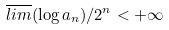<formula> <loc_0><loc_0><loc_500><loc_500>\overline { l i m } ( \log a _ { n } ) / 2 ^ { n } < + \infty</formula> 